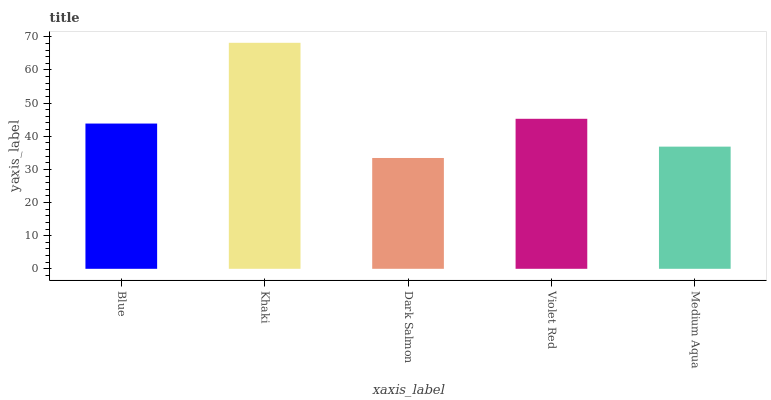Is Khaki the minimum?
Answer yes or no. No. Is Dark Salmon the maximum?
Answer yes or no. No. Is Khaki greater than Dark Salmon?
Answer yes or no. Yes. Is Dark Salmon less than Khaki?
Answer yes or no. Yes. Is Dark Salmon greater than Khaki?
Answer yes or no. No. Is Khaki less than Dark Salmon?
Answer yes or no. No. Is Blue the high median?
Answer yes or no. Yes. Is Blue the low median?
Answer yes or no. Yes. Is Violet Red the high median?
Answer yes or no. No. Is Violet Red the low median?
Answer yes or no. No. 